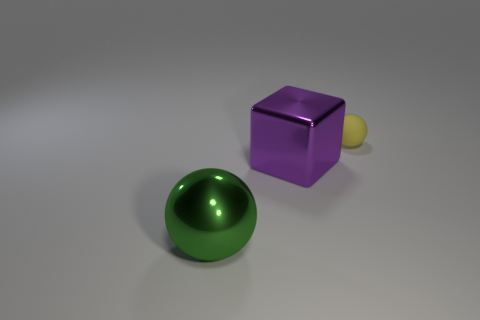Add 2 green metal things. How many objects exist? 5 Subtract all blocks. How many objects are left? 2 Subtract all green things. Subtract all metallic spheres. How many objects are left? 1 Add 3 purple objects. How many purple objects are left? 4 Add 2 large yellow matte cylinders. How many large yellow matte cylinders exist? 2 Subtract 0 cyan cylinders. How many objects are left? 3 